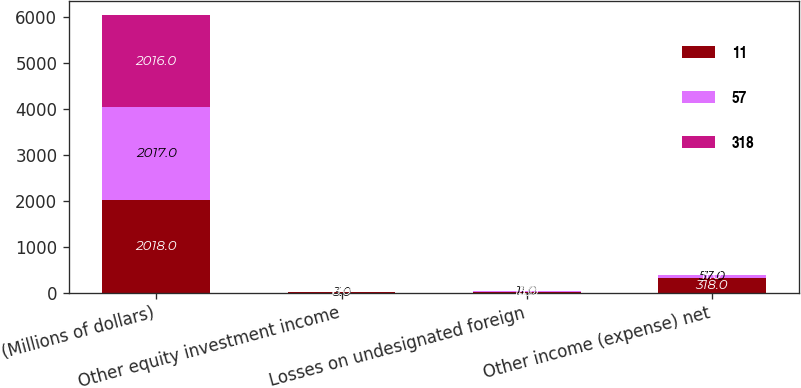Convert chart to OTSL. <chart><loc_0><loc_0><loc_500><loc_500><stacked_bar_chart><ecel><fcel>(Millions of dollars)<fcel>Other equity investment income<fcel>Losses on undesignated foreign<fcel>Other income (expense) net<nl><fcel>11<fcel>2018<fcel>8<fcel>14<fcel>318<nl><fcel>57<fcel>2017<fcel>3<fcel>11<fcel>57<nl><fcel>318<fcel>2016<fcel>8<fcel>3<fcel>11<nl></chart> 